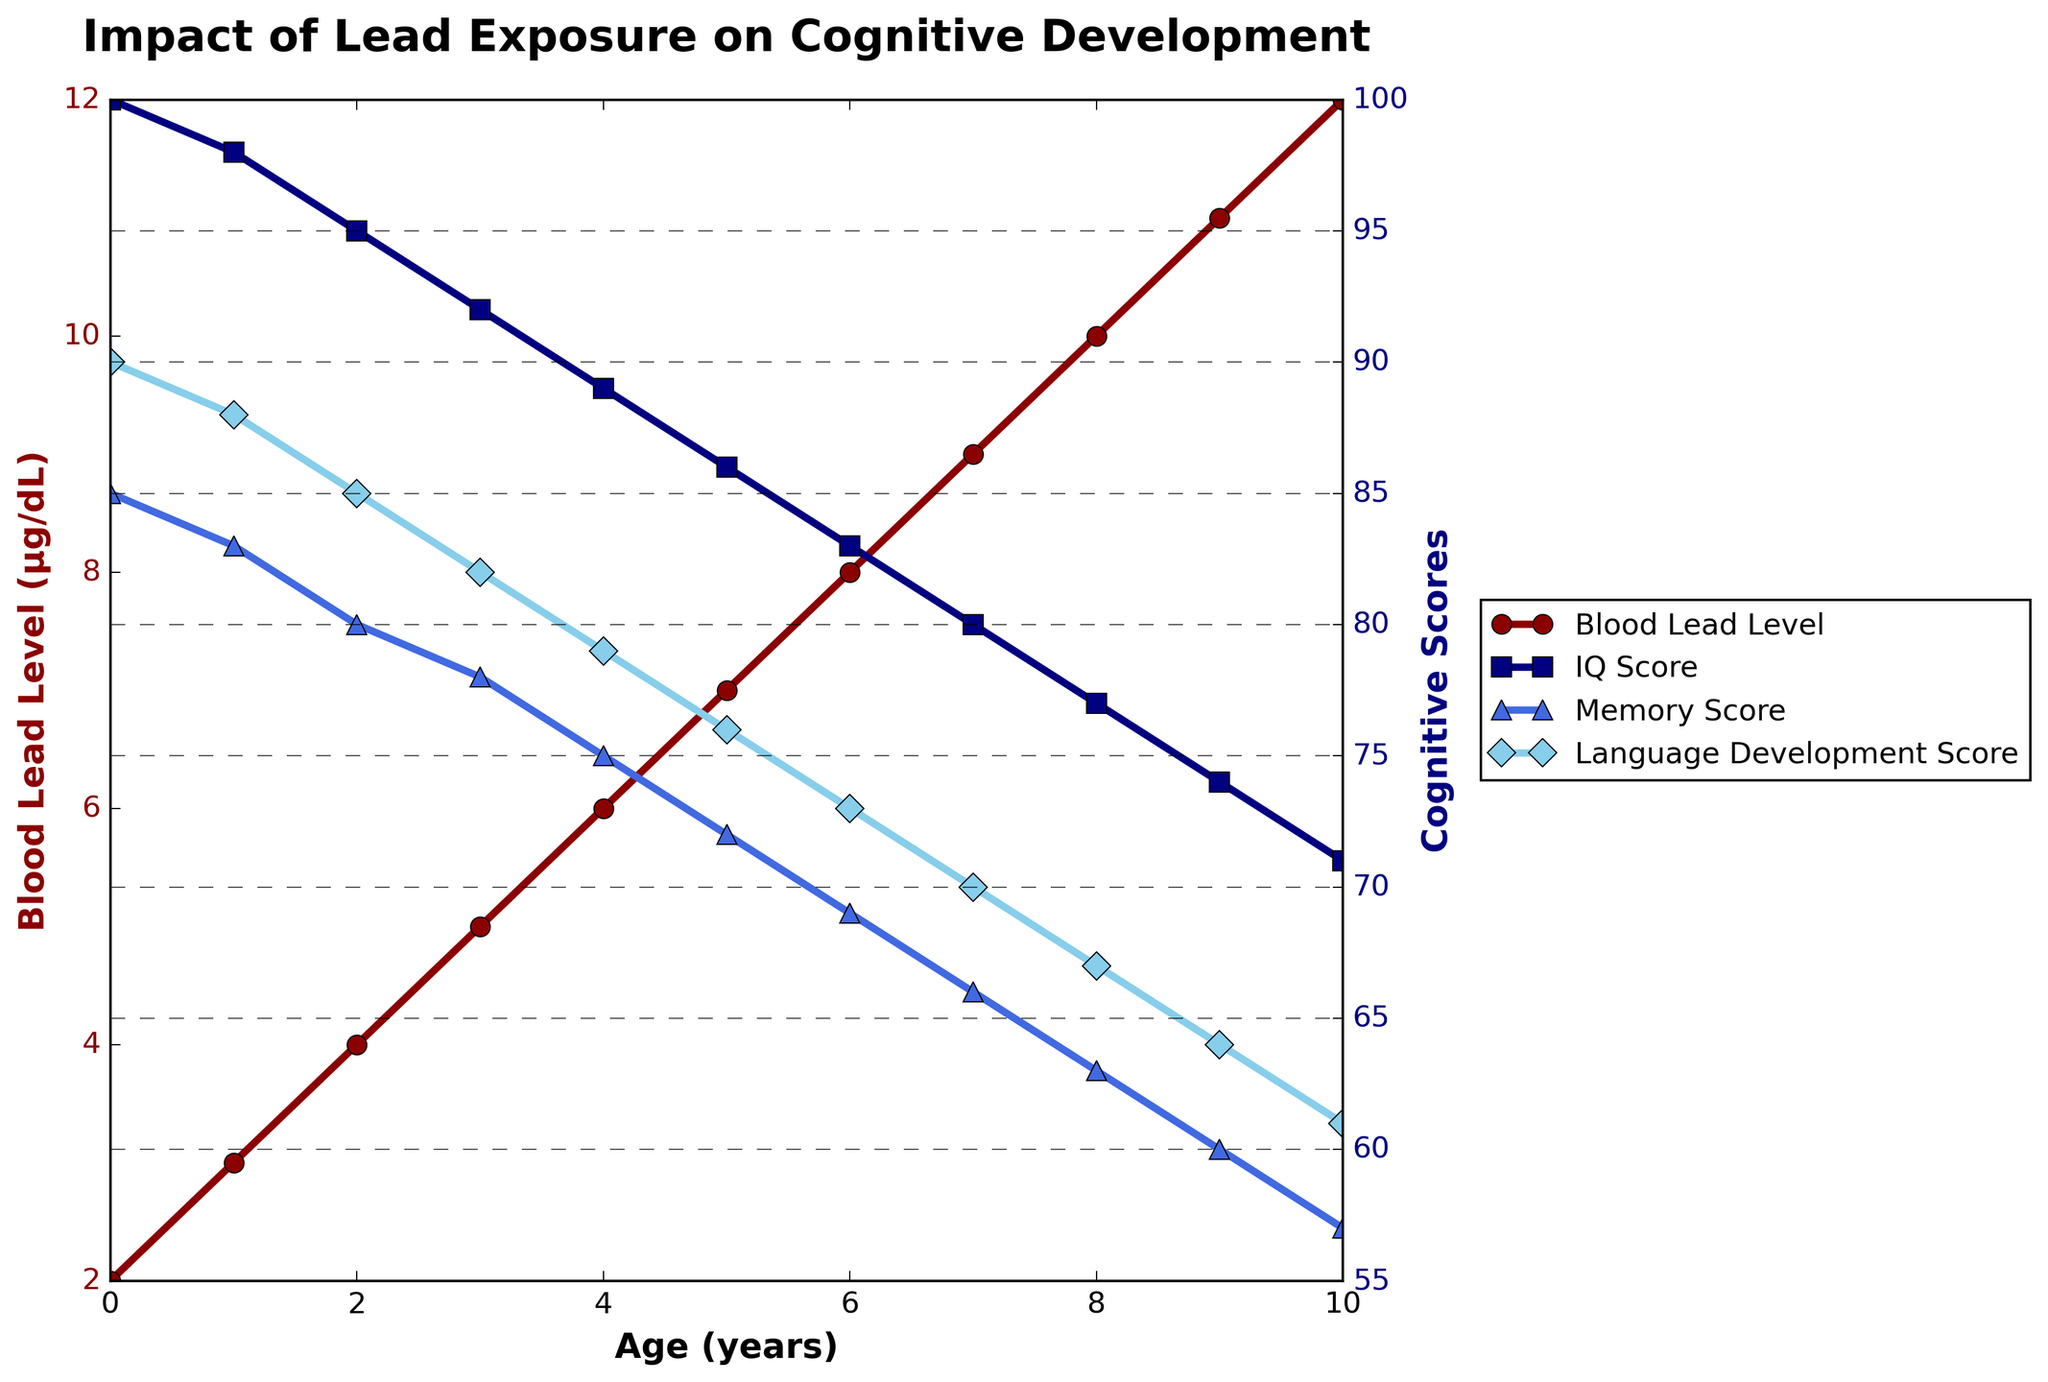What's the trend of Blood Lead Level from birth to age 10? The Blood Lead Level increases as age increases. By visually inspecting the red line on the chart, one can see that it steadily rises from 2 μg/dL at birth to 12 μg/dL at age 10.
Answer: Increases At which age does the IQ Score show the steepest decline? To find the steepest decline, look for the largest drop in the blue line representing IQ Score between consecutive ages. The steepest decline occurs from age 2 (IQ Score 95) to age 3 (IQ Score 92), a drop of 3 points.
Answer: Age 2 to 3 What is the overall trend in Memory Score as age increases? The Memory Score consistently decreases as age increases. The trend can be observed by following the triangle markers that diminish from 85 at birth to 57 at age 10.
Answer: Decreases How do the trends in Blood Lead Level and IQ Score compare? Blood Lead Level (red line) increases, while IQ Score (blue line) decreases as age increases. This visual comparison shows an inverse relationship between the two variables.
Answer: Inversely related What is the difference in the Language Development Score between ages 5 and 10? Age 5 has a Language Development Score of 76 and age 10 has a score of 61. The difference is 76 - 61 = 15.
Answer: 15 Which cognitive development measure shows the largest drop from birth to age 10? Compare the differences in each cognitive development measure from birth to age 10. IQ Score drops from 100 to 71 (a difference of 29), Memory Score drops from 85 to 57 (a difference of 28), and Language Development Score drops from 90 to 61 (a difference of 29). Both IQ Score and Language Development Score show the largest drop of 29 points.
Answer: IQ Score and Language Development Score At which age do the Attention Span and Blood Lead Level intersect visually? Visually locate the point where the red line (Blood Lead Level) intersects the purple dashed line for Attention Span. This occurs at around age 5 where both values are approximately at 12.
Answer: Age 5 By how much does the IQ Score at age 6 differ from the IQ Score at age 2? The IQ Score at age 6 is 83 while at age 2 it is 95. The difference is 95 - 83 = 12.
Answer: 12 What is the average IQ Score from birth to age 10? Sum the IQ Scores and divide by the number of ages: (100 + 98 + 95 + 92 + 89 + 86 + 83 + 80 + 77 + 74 + 71) / 11 = 925 / 11 = 84.09.
Answer: 84.09 Which cognitive measure has the lowest score at age 10? At age 10, compare the scores of IQ Score (71), Memory Score (57), and Language Development Score (61). The lowest score is Memory Score, which is 57.
Answer: Memory Score 